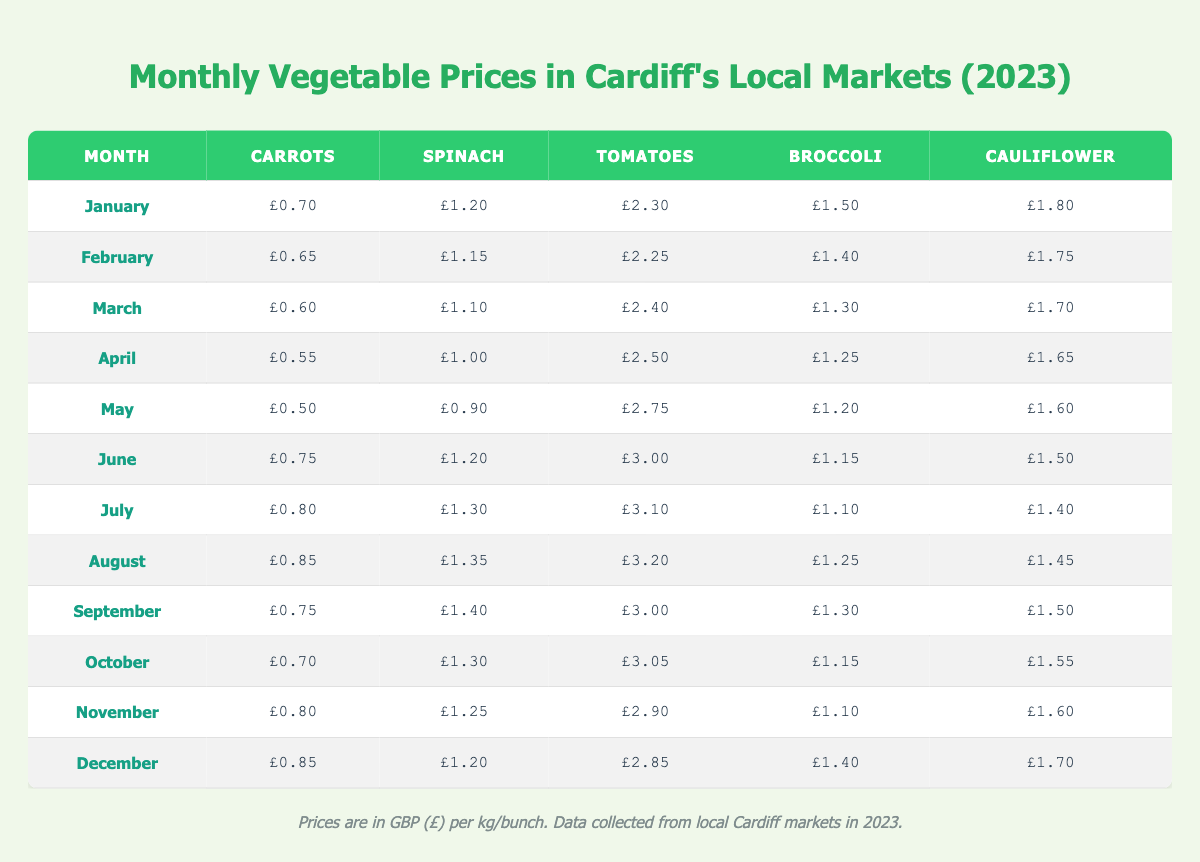What is the price of Spinach in March? The table shows the price of Spinach under the month of March, which is listed as £1.10.
Answer: £1.10 What was the lowest price for Cauliflower in 2023? By reviewing the Cauliflower prices across all months, April shows the lowest price at £1.65.
Answer: £1.65 Which month had the highest price for Tomatoes? The highest price for Tomatoes is found in August, where it is listed as £3.20.
Answer: £3.20 What is the average price of Carrots over the months from January to March? To find the average, we sum the prices of Carrots (0.70 + 0.65 + 0.60 = 1.95) and then divide by 3, which gives an average of £0.65.
Answer: £0.65 Did the price of Broccoli increase or decrease from February to April? In February, Broccoli was £1.40 and in April, it was £1.25. Since £1.25 is less than £1.40, the price decreased.
Answer: Decreased What is the price difference for Spinach between June and August? The Spinach price in June is £1.20 and in August is £1.35. The difference is calculated as £1.35 - £1.20 = £0.15.
Answer: £0.15 How much did the price of Tomatoes increase from April to June? The price of Tomatoes in April is £2.50 and in June is £3.00. The increase is £3.00 - £2.50 = £0.50.
Answer: £0.50 Which vegetable consistently had the lowest price from January to April? By comparing the prices of all vegetables in January, February, March, and April, Carrots consistently had the lowest price throughout these months.
Answer: Carrots What was the average price of Broccoli from May to December? First, we sum the prices of Broccoli from May (£1.20), June (£1.15), July (£1.10), August (£1.25), September (£1.30), October (£1.15), November (£1.10), and December (£1.40). The total sum is £9.20 for 8 months, giving an average of £1.15.
Answer: £1.15 Is the price of Cauliflower the same in November and December? The price for Cauliflower in November is £1.60 and in December is £1.70. Since they are not equal, the statement is false.
Answer: No 